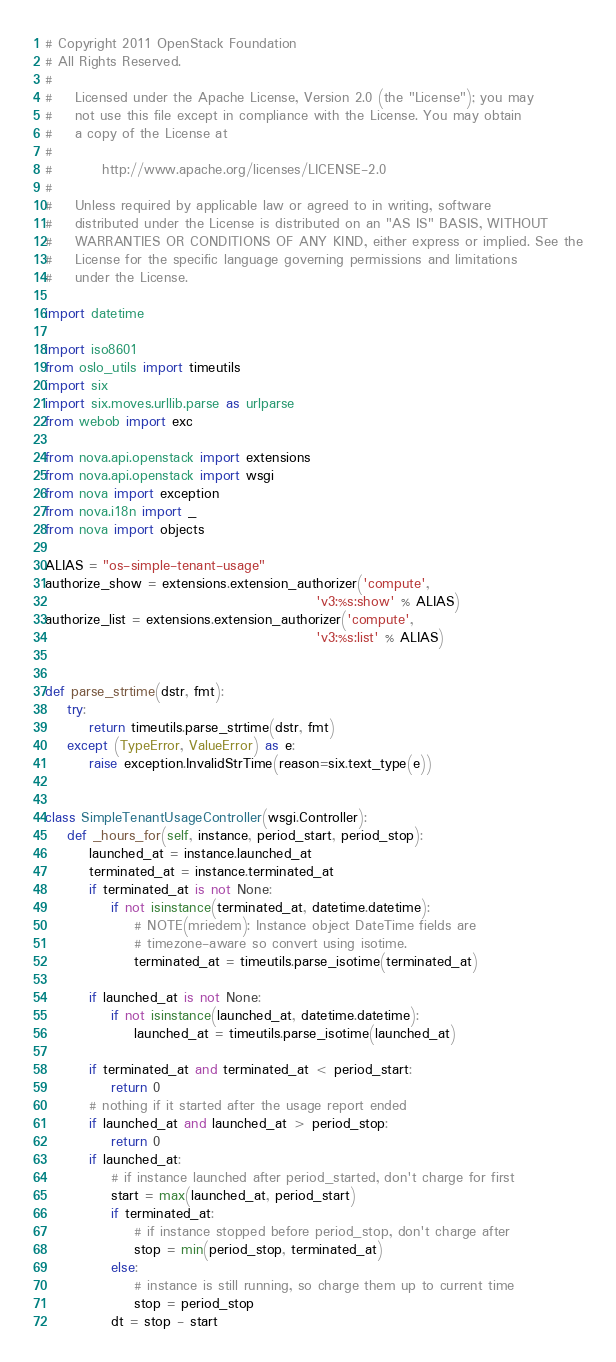<code> <loc_0><loc_0><loc_500><loc_500><_Python_># Copyright 2011 OpenStack Foundation
# All Rights Reserved.
#
#    Licensed under the Apache License, Version 2.0 (the "License"); you may
#    not use this file except in compliance with the License. You may obtain
#    a copy of the License at
#
#         http://www.apache.org/licenses/LICENSE-2.0
#
#    Unless required by applicable law or agreed to in writing, software
#    distributed under the License is distributed on an "AS IS" BASIS, WITHOUT
#    WARRANTIES OR CONDITIONS OF ANY KIND, either express or implied. See the
#    License for the specific language governing permissions and limitations
#    under the License.

import datetime

import iso8601
from oslo_utils import timeutils
import six
import six.moves.urllib.parse as urlparse
from webob import exc

from nova.api.openstack import extensions
from nova.api.openstack import wsgi
from nova import exception
from nova.i18n import _
from nova import objects

ALIAS = "os-simple-tenant-usage"
authorize_show = extensions.extension_authorizer('compute',
                                                 'v3:%s:show' % ALIAS)
authorize_list = extensions.extension_authorizer('compute',
                                                 'v3:%s:list' % ALIAS)


def parse_strtime(dstr, fmt):
    try:
        return timeutils.parse_strtime(dstr, fmt)
    except (TypeError, ValueError) as e:
        raise exception.InvalidStrTime(reason=six.text_type(e))


class SimpleTenantUsageController(wsgi.Controller):
    def _hours_for(self, instance, period_start, period_stop):
        launched_at = instance.launched_at
        terminated_at = instance.terminated_at
        if terminated_at is not None:
            if not isinstance(terminated_at, datetime.datetime):
                # NOTE(mriedem): Instance object DateTime fields are
                # timezone-aware so convert using isotime.
                terminated_at = timeutils.parse_isotime(terminated_at)

        if launched_at is not None:
            if not isinstance(launched_at, datetime.datetime):
                launched_at = timeutils.parse_isotime(launched_at)

        if terminated_at and terminated_at < period_start:
            return 0
        # nothing if it started after the usage report ended
        if launched_at and launched_at > period_stop:
            return 0
        if launched_at:
            # if instance launched after period_started, don't charge for first
            start = max(launched_at, period_start)
            if terminated_at:
                # if instance stopped before period_stop, don't charge after
                stop = min(period_stop, terminated_at)
            else:
                # instance is still running, so charge them up to current time
                stop = period_stop
            dt = stop - start</code> 